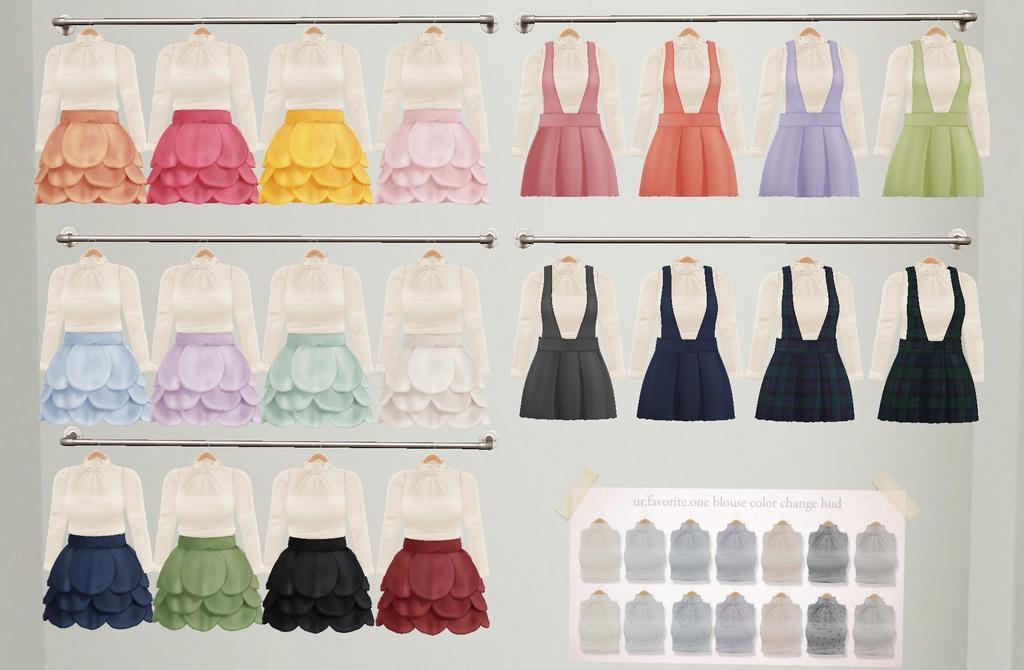In one or two sentences, can you explain what this image depicts? In this image we can see a poster of few clothes and rods and a poster with text and images of clothes is attached to the poster. 